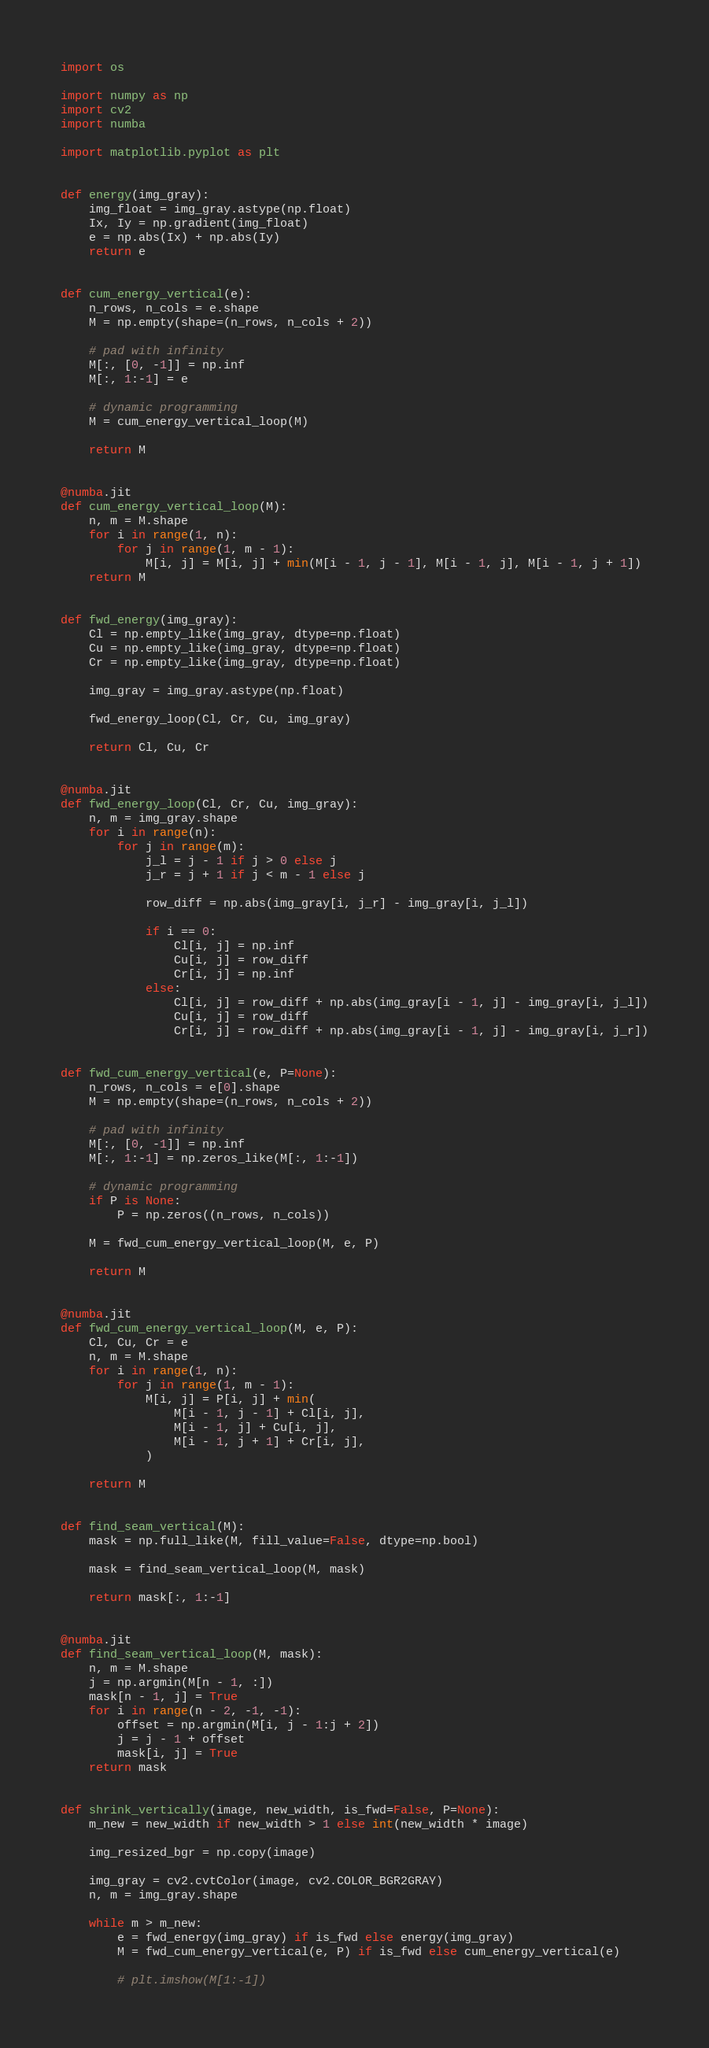Convert code to text. <code><loc_0><loc_0><loc_500><loc_500><_Python_>import os

import numpy as np
import cv2
import numba

import matplotlib.pyplot as plt


def energy(img_gray):
    img_float = img_gray.astype(np.float)
    Ix, Iy = np.gradient(img_float)
    e = np.abs(Ix) + np.abs(Iy)
    return e


def cum_energy_vertical(e):
    n_rows, n_cols = e.shape
    M = np.empty(shape=(n_rows, n_cols + 2))

    # pad with infinity
    M[:, [0, -1]] = np.inf
    M[:, 1:-1] = e

    # dynamic programming
    M = cum_energy_vertical_loop(M)

    return M


@numba.jit
def cum_energy_vertical_loop(M):
    n, m = M.shape
    for i in range(1, n):
        for j in range(1, m - 1):
            M[i, j] = M[i, j] + min(M[i - 1, j - 1], M[i - 1, j], M[i - 1, j + 1])
    return M


def fwd_energy(img_gray):
    Cl = np.empty_like(img_gray, dtype=np.float)
    Cu = np.empty_like(img_gray, dtype=np.float)
    Cr = np.empty_like(img_gray, dtype=np.float)

    img_gray = img_gray.astype(np.float)

    fwd_energy_loop(Cl, Cr, Cu, img_gray)

    return Cl, Cu, Cr


@numba.jit
def fwd_energy_loop(Cl, Cr, Cu, img_gray):
    n, m = img_gray.shape
    for i in range(n):
        for j in range(m):
            j_l = j - 1 if j > 0 else j
            j_r = j + 1 if j < m - 1 else j

            row_diff = np.abs(img_gray[i, j_r] - img_gray[i, j_l])

            if i == 0:
                Cl[i, j] = np.inf
                Cu[i, j] = row_diff
                Cr[i, j] = np.inf
            else:
                Cl[i, j] = row_diff + np.abs(img_gray[i - 1, j] - img_gray[i, j_l])
                Cu[i, j] = row_diff
                Cr[i, j] = row_diff + np.abs(img_gray[i - 1, j] - img_gray[i, j_r])


def fwd_cum_energy_vertical(e, P=None):
    n_rows, n_cols = e[0].shape
    M = np.empty(shape=(n_rows, n_cols + 2))

    # pad with infinity
    M[:, [0, -1]] = np.inf
    M[:, 1:-1] = np.zeros_like(M[:, 1:-1])

    # dynamic programming
    if P is None:
        P = np.zeros((n_rows, n_cols))

    M = fwd_cum_energy_vertical_loop(M, e, P)

    return M


@numba.jit
def fwd_cum_energy_vertical_loop(M, e, P):
    Cl, Cu, Cr = e
    n, m = M.shape
    for i in range(1, n):
        for j in range(1, m - 1):
            M[i, j] = P[i, j] + min(
                M[i - 1, j - 1] + Cl[i, j],
                M[i - 1, j] + Cu[i, j],
                M[i - 1, j + 1] + Cr[i, j],
            )

    return M


def find_seam_vertical(M):
    mask = np.full_like(M, fill_value=False, dtype=np.bool)

    mask = find_seam_vertical_loop(M, mask)

    return mask[:, 1:-1]


@numba.jit
def find_seam_vertical_loop(M, mask):
    n, m = M.shape
    j = np.argmin(M[n - 1, :])
    mask[n - 1, j] = True
    for i in range(n - 2, -1, -1):
        offset = np.argmin(M[i, j - 1:j + 2])
        j = j - 1 + offset
        mask[i, j] = True
    return mask


def shrink_vertically(image, new_width, is_fwd=False, P=None):
    m_new = new_width if new_width > 1 else int(new_width * image)

    img_resized_bgr = np.copy(image)

    img_gray = cv2.cvtColor(image, cv2.COLOR_BGR2GRAY)
    n, m = img_gray.shape

    while m > m_new:
        e = fwd_energy(img_gray) if is_fwd else energy(img_gray)
        M = fwd_cum_energy_vertical(e, P) if is_fwd else cum_energy_vertical(e)

        # plt.imshow(M[1:-1])</code> 